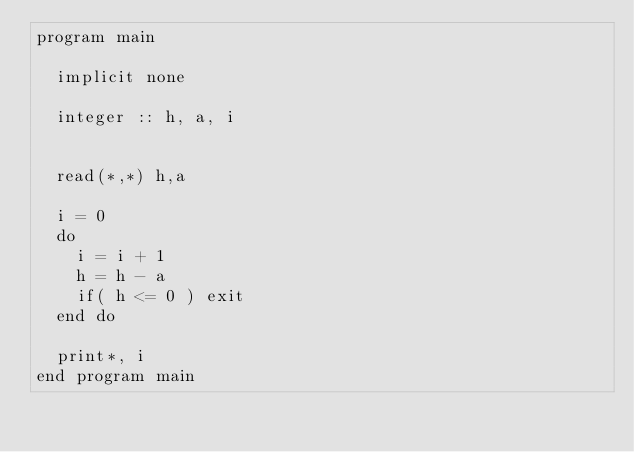Convert code to text. <code><loc_0><loc_0><loc_500><loc_500><_FORTRAN_>program main

  implicit none
  
  integer :: h, a, i
  

  read(*,*) h,a

  i = 0
  do 
    i = i + 1
    h = h - a 
    if( h <= 0 ) exit
  end do

  print*, i
end program main
</code> 